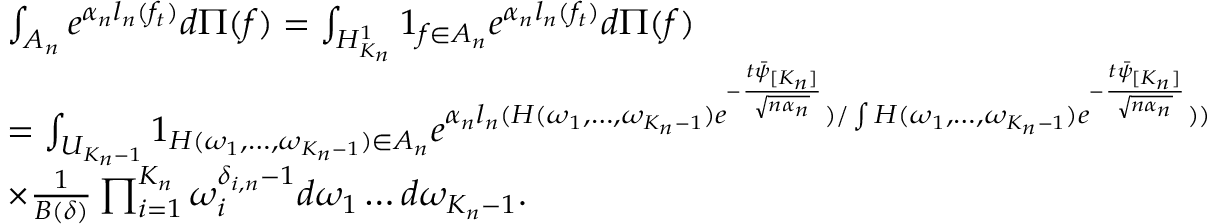<formula> <loc_0><loc_0><loc_500><loc_500>\begin{array} { r l } & { \int _ { A _ { n } } e ^ { \alpha _ { n } l _ { n } ( f _ { t } ) } d \Pi ( f ) = \int _ { H _ { K _ { n } } ^ { 1 } } 1 _ { f \in A _ { n } } e ^ { \alpha _ { n } l _ { n } ( f _ { t } ) } d \Pi ( f ) } \\ & { = \int _ { U _ { K _ { n } - 1 } } 1 _ { H ( \omega _ { 1 } , \dots , \omega _ { K _ { n } - 1 } ) \in A _ { n } } e ^ { \alpha _ { n } l _ { n } ( H ( \omega _ { 1 } , \dots , \omega _ { K _ { n } - 1 } ) e ^ { - \frac { t \bar { \psi } _ { [ K _ { n } ] } } { \sqrt { n \alpha _ { n } } } } ) / \int H ( \omega _ { 1 } , \dots , \omega _ { K _ { n } - 1 } ) e ^ { - \frac { t \bar { \psi } _ { [ K _ { n } ] } } { \sqrt { n \alpha _ { n } } } } ) ) } } \\ & { \times \frac { 1 } { B ( \delta ) } \prod _ { i = 1 } ^ { K _ { n } } \omega _ { i } ^ { \delta _ { i , n } - 1 } d \omega _ { 1 } \dots d \omega _ { K _ { n } - 1 } . } \end{array}</formula> 